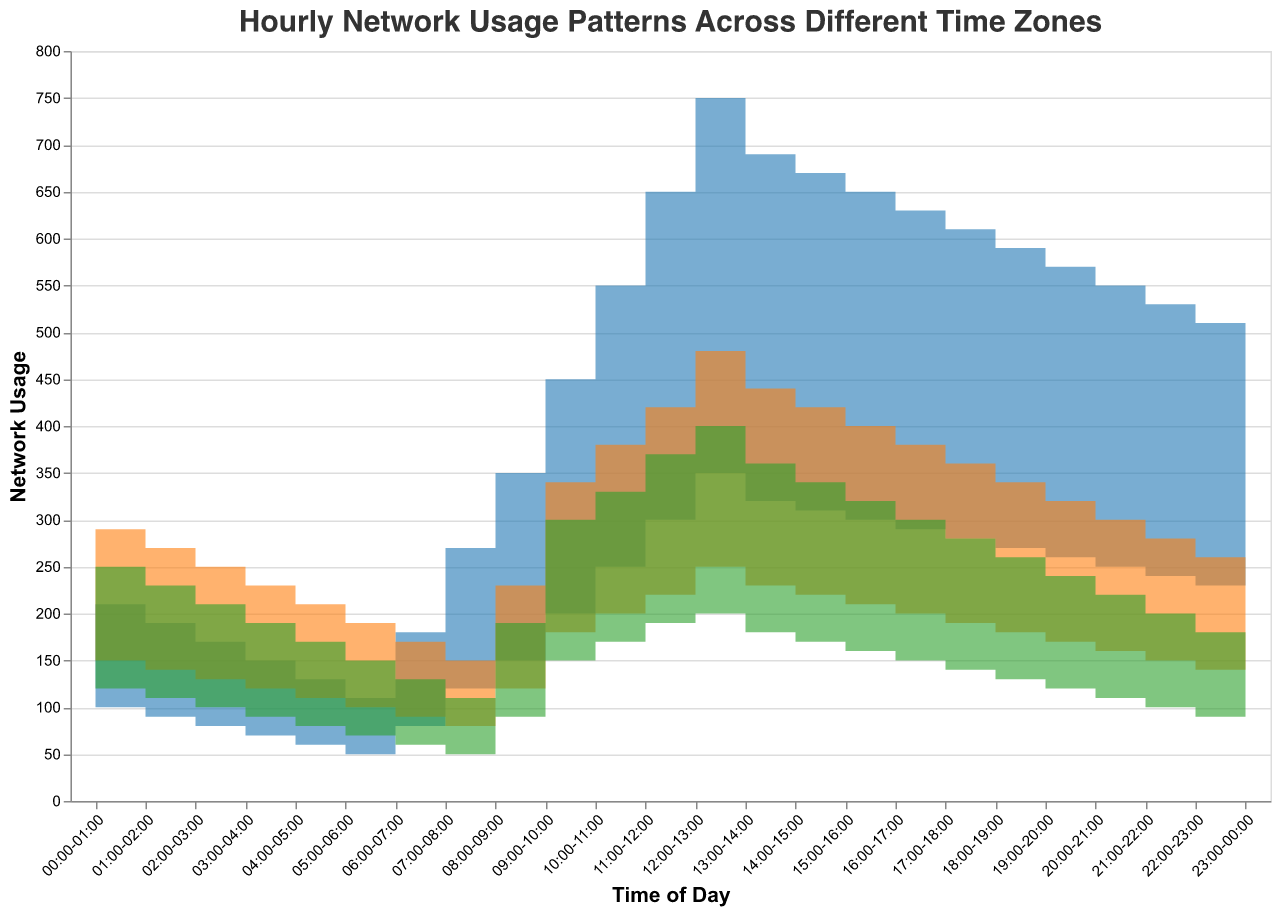What is the title of the chart? The title of the chart is displayed at the top and reads "Hourly Network Usage Patterns Across Different Time Zones."
Answer: Hourly Network Usage Patterns Across Different Time Zones Which usage type shows the highest peak, and at what time does it occur? The Residential usage type shows the highest peak, which occurs at 12:00-13:00 with a value marked clearly higher than others.
Answer: Residential, 12:00-13:00 During which time period is the Commercial usage consistently higher than both Residential and Educational usage in the UTC-8 time zone? By observing the step area sections of the chart, the only time period where Commercial Usage consistently tops both Residential and Educational Usage in UTC-8 is from 00:00-06:00.
Answer: 00:00-06:00 (UTC-8) What are the lowest observed values for Residential, Commercial, and Educational usage in the UTC+1 time zone? By scanning the bottom edges of each colored area for UTC+1, the lowest observed values are Residential = 60, Commercial = 70, and Educational = 60, typically occurring around 05:00-06:00.
Answer: Residential: 60, Commercial: 70, Educational: 60 In what time period is the Educational usage highest, irrespective of time zones? Across both time zones, the Educational usage reaches its peak value between 12:00-13:00 in UTC+1 with a noticeably higher step area.
Answer: 12:00-13:00 Compare the Residential usage between UTC-8 and UTC+1 at 09:00-10:00. Which is higher? Looking at the respective steps for 09:00-10:00, 200 (UTC-8) and 250 (UTC+1), the Residential usage is higher in UTC+1.
Answer: UTC+1 What is the average Educational usage in the UTC-8 time zone during the peak hour of Residential usage? The peak hour of Residential usage in UTC-8 is 12:00-13:00, and during this time the Educational usage is 200. Since it is a single data point, the average is 200.
Answer: 200 Which time zone shows higher overall Commercial usage, and what is the total difference? Sum the Commercial usage values across each time zone. Total for UTC-8: 4340, UTC+1: 4260. UTC-8's value is 80 units higher.
Answer: UTC-8, 80 How does the trend of Residential usage compare between the two time zones from 22:00-23:00 to 23:00-00:00? Both time zones exhibit a decreasing trend, but by visual inspection, the decrease is more substantial in the UTC+1 from 280 to 270, while UTC-8 decreases from 230 to 220.
Answer: UTC+1: larger decrease Between 07:00-08:00 and 08:00-09:00 in UTC-8, which usage type has the greatest percentage increase? Residential usage increases from 120 to 150, which is a 25% increase (150-120)/120*100%. Commercial usage increases from 80 to 120, making it a 50% increase (120-80)/80*100%. Educational usage increases from 50 to 90, a 80% increase (90-50)/50*100%. The highest percentage increase is in Educational usage.
Answer: Educational 